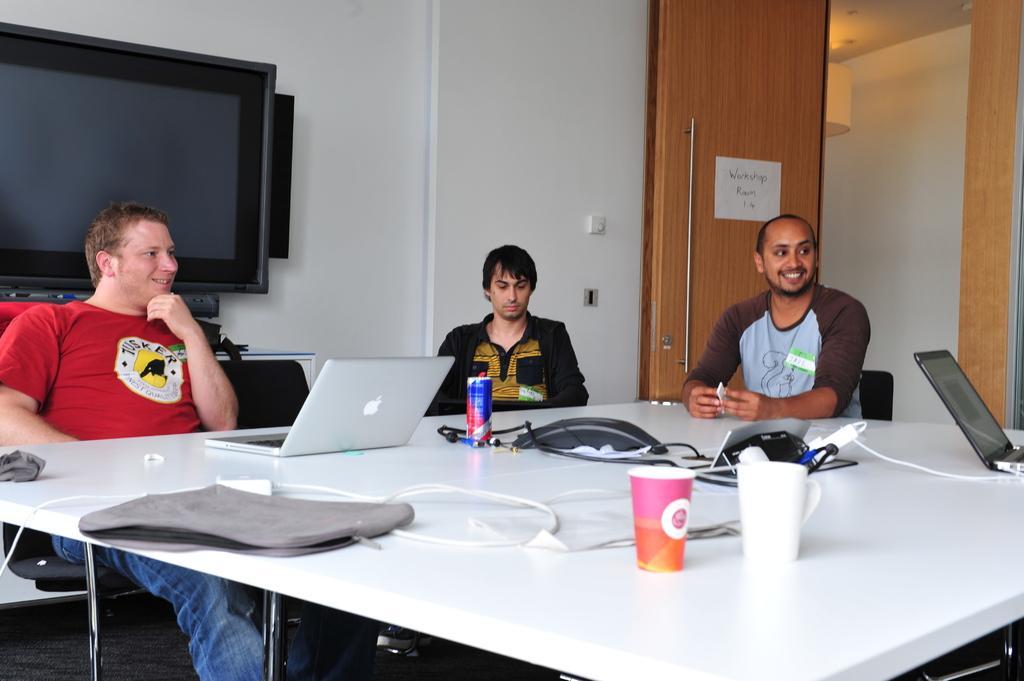Please provide a concise description of this image. This is a picture taken in a room, there are three people sitting on chairs in front of these people there is a table on the table there are glasses, thin, laptops and cables. Behind the people there is a wall, wooden door and television. 